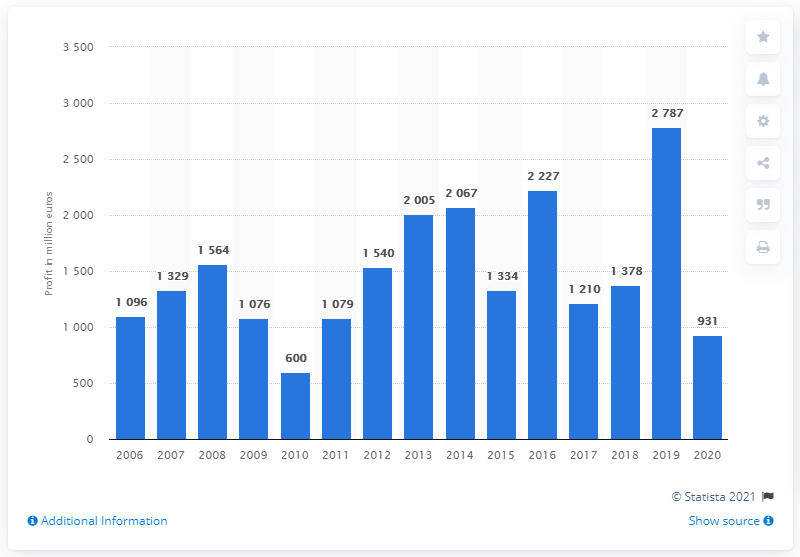Mention a couple of crucial points in this snapshot. The profit of Richemont SA in FY2020 was 931. 